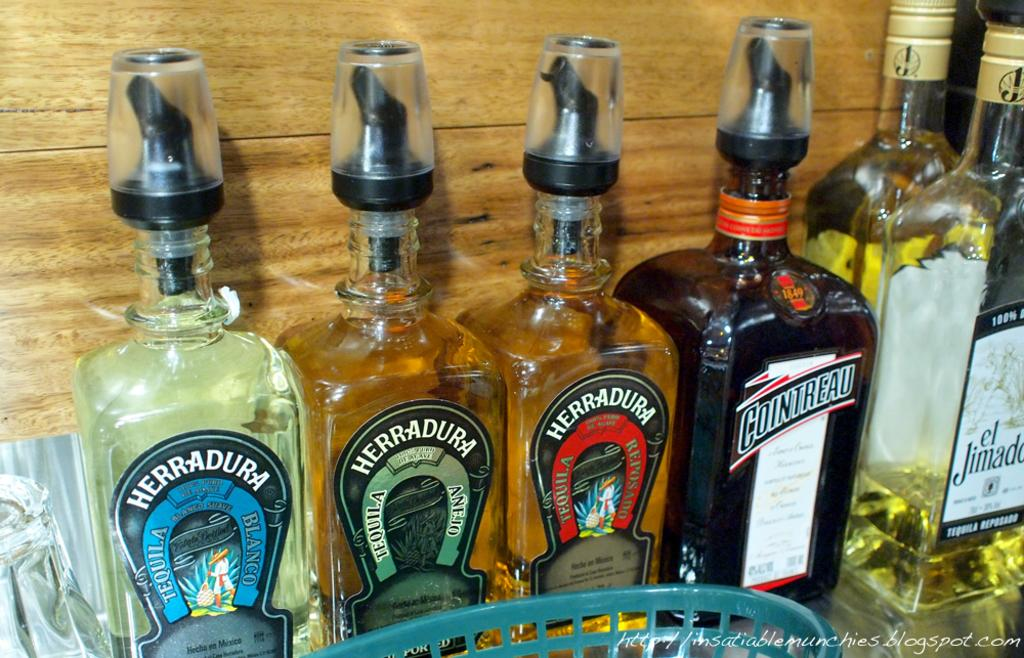<image>
Describe the image concisely. A couple of Herradura tequila bottles are displayed on a shelf. 